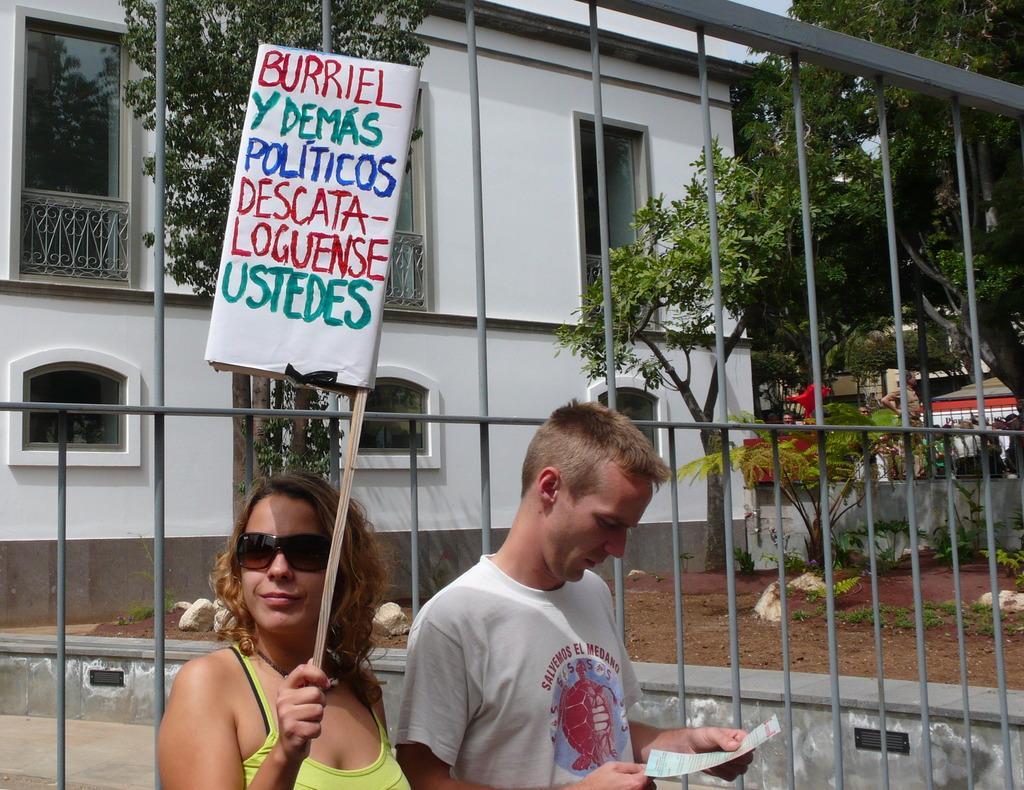Please provide a concise description of this image. This image is taken outdoors. In the background there is a building. There are few trees. There are few plants. There is a fence. There are a few rocks on the ground. In the middle of the image there is a man and a woman standing on the ground. A woman is holding a placard with a text on it and a man is holding a paper in his hands. 